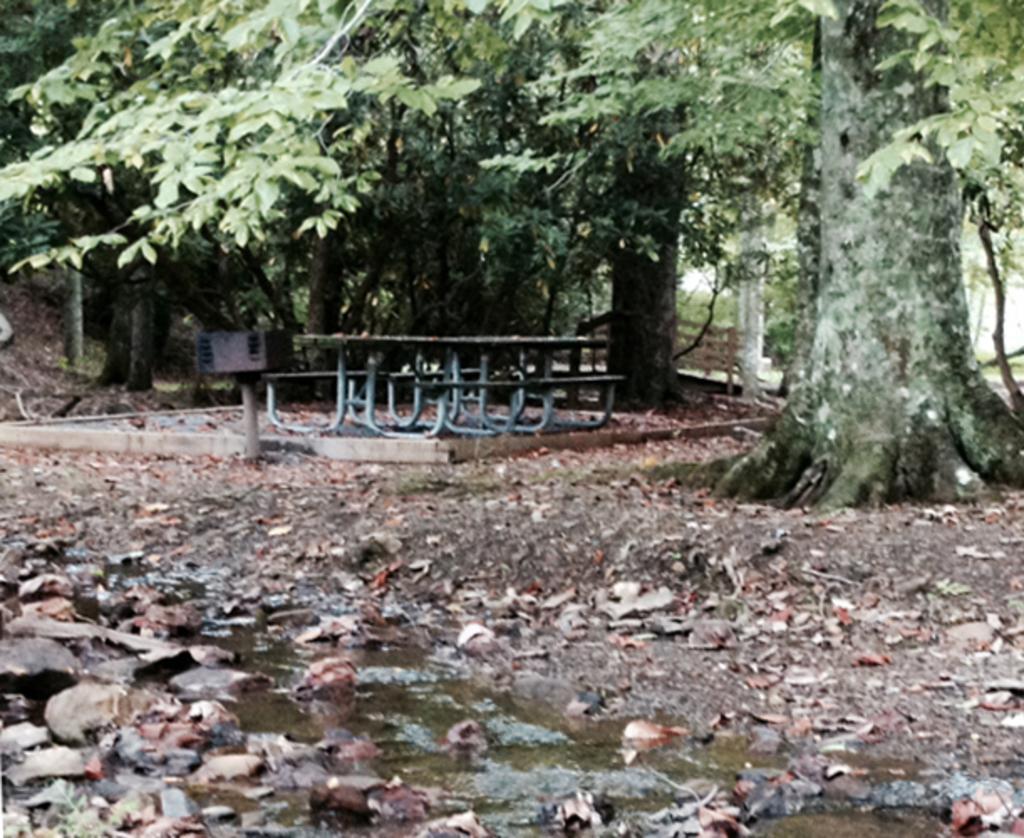Could you give a brief overview of what you see in this image? On left side, there are water and stones on the ground. In the background, there are trees, benches, a table and dry leaves on the ground. 